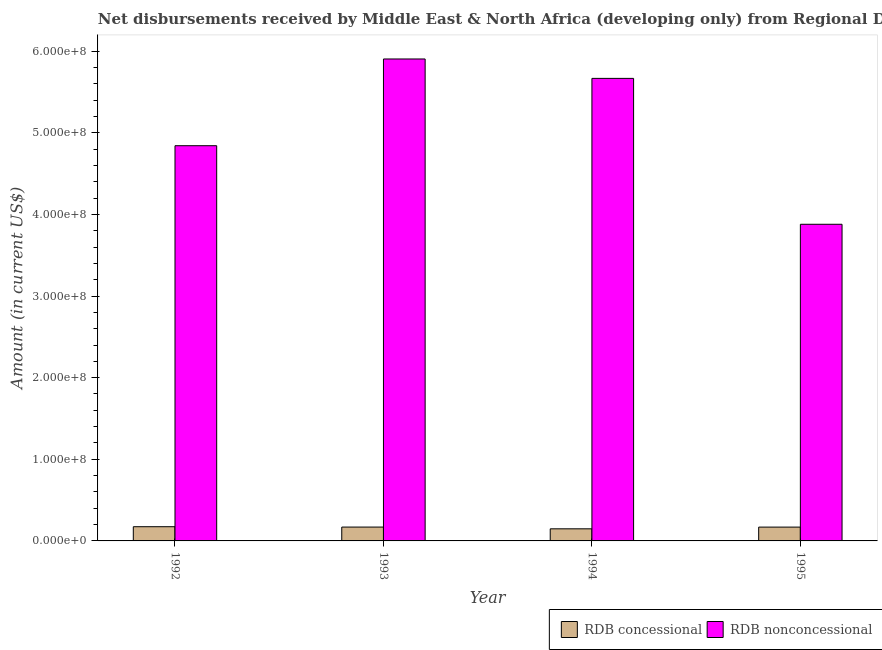How many different coloured bars are there?
Provide a short and direct response. 2. How many groups of bars are there?
Keep it short and to the point. 4. How many bars are there on the 2nd tick from the right?
Offer a very short reply. 2. What is the net concessional disbursements from rdb in 1995?
Provide a short and direct response. 1.69e+07. Across all years, what is the maximum net concessional disbursements from rdb?
Offer a terse response. 1.74e+07. Across all years, what is the minimum net concessional disbursements from rdb?
Give a very brief answer. 1.48e+07. What is the total net non concessional disbursements from rdb in the graph?
Ensure brevity in your answer.  2.03e+09. What is the difference between the net concessional disbursements from rdb in 1992 and that in 1995?
Offer a terse response. 4.81e+05. What is the difference between the net non concessional disbursements from rdb in 1994 and the net concessional disbursements from rdb in 1995?
Keep it short and to the point. 1.79e+08. What is the average net concessional disbursements from rdb per year?
Offer a very short reply. 1.65e+07. What is the ratio of the net concessional disbursements from rdb in 1992 to that in 1994?
Make the answer very short. 1.17. Is the net concessional disbursements from rdb in 1993 less than that in 1994?
Offer a terse response. No. What is the difference between the highest and the second highest net non concessional disbursements from rdb?
Give a very brief answer. 2.38e+07. What is the difference between the highest and the lowest net concessional disbursements from rdb?
Give a very brief answer. 2.59e+06. What does the 1st bar from the left in 1994 represents?
Your answer should be compact. RDB concessional. What does the 1st bar from the right in 1992 represents?
Make the answer very short. RDB nonconcessional. Are all the bars in the graph horizontal?
Keep it short and to the point. No. Are the values on the major ticks of Y-axis written in scientific E-notation?
Provide a succinct answer. Yes. Does the graph contain any zero values?
Keep it short and to the point. No. Does the graph contain grids?
Ensure brevity in your answer.  No. Where does the legend appear in the graph?
Give a very brief answer. Bottom right. How many legend labels are there?
Offer a very short reply. 2. What is the title of the graph?
Keep it short and to the point. Net disbursements received by Middle East & North Africa (developing only) from Regional Development Bank. What is the Amount (in current US$) of RDB concessional in 1992?
Offer a very short reply. 1.74e+07. What is the Amount (in current US$) of RDB nonconcessional in 1992?
Make the answer very short. 4.84e+08. What is the Amount (in current US$) of RDB concessional in 1993?
Your response must be concise. 1.70e+07. What is the Amount (in current US$) in RDB nonconcessional in 1993?
Keep it short and to the point. 5.90e+08. What is the Amount (in current US$) in RDB concessional in 1994?
Your answer should be compact. 1.48e+07. What is the Amount (in current US$) of RDB nonconcessional in 1994?
Your answer should be compact. 5.67e+08. What is the Amount (in current US$) in RDB concessional in 1995?
Keep it short and to the point. 1.69e+07. What is the Amount (in current US$) of RDB nonconcessional in 1995?
Offer a very short reply. 3.88e+08. Across all years, what is the maximum Amount (in current US$) in RDB concessional?
Provide a short and direct response. 1.74e+07. Across all years, what is the maximum Amount (in current US$) of RDB nonconcessional?
Your answer should be compact. 5.90e+08. Across all years, what is the minimum Amount (in current US$) in RDB concessional?
Your answer should be very brief. 1.48e+07. Across all years, what is the minimum Amount (in current US$) of RDB nonconcessional?
Provide a succinct answer. 3.88e+08. What is the total Amount (in current US$) of RDB concessional in the graph?
Your response must be concise. 6.61e+07. What is the total Amount (in current US$) in RDB nonconcessional in the graph?
Give a very brief answer. 2.03e+09. What is the difference between the Amount (in current US$) of RDB concessional in 1992 and that in 1993?
Offer a very short reply. 4.39e+05. What is the difference between the Amount (in current US$) of RDB nonconcessional in 1992 and that in 1993?
Provide a short and direct response. -1.06e+08. What is the difference between the Amount (in current US$) of RDB concessional in 1992 and that in 1994?
Your answer should be compact. 2.59e+06. What is the difference between the Amount (in current US$) of RDB nonconcessional in 1992 and that in 1994?
Give a very brief answer. -8.25e+07. What is the difference between the Amount (in current US$) in RDB concessional in 1992 and that in 1995?
Your answer should be compact. 4.81e+05. What is the difference between the Amount (in current US$) in RDB nonconcessional in 1992 and that in 1995?
Provide a short and direct response. 9.62e+07. What is the difference between the Amount (in current US$) in RDB concessional in 1993 and that in 1994?
Your answer should be very brief. 2.15e+06. What is the difference between the Amount (in current US$) of RDB nonconcessional in 1993 and that in 1994?
Offer a terse response. 2.38e+07. What is the difference between the Amount (in current US$) in RDB concessional in 1993 and that in 1995?
Make the answer very short. 4.20e+04. What is the difference between the Amount (in current US$) in RDB nonconcessional in 1993 and that in 1995?
Offer a very short reply. 2.02e+08. What is the difference between the Amount (in current US$) in RDB concessional in 1994 and that in 1995?
Provide a succinct answer. -2.11e+06. What is the difference between the Amount (in current US$) in RDB nonconcessional in 1994 and that in 1995?
Give a very brief answer. 1.79e+08. What is the difference between the Amount (in current US$) in RDB concessional in 1992 and the Amount (in current US$) in RDB nonconcessional in 1993?
Your answer should be compact. -5.73e+08. What is the difference between the Amount (in current US$) in RDB concessional in 1992 and the Amount (in current US$) in RDB nonconcessional in 1994?
Keep it short and to the point. -5.49e+08. What is the difference between the Amount (in current US$) of RDB concessional in 1992 and the Amount (in current US$) of RDB nonconcessional in 1995?
Make the answer very short. -3.70e+08. What is the difference between the Amount (in current US$) in RDB concessional in 1993 and the Amount (in current US$) in RDB nonconcessional in 1994?
Give a very brief answer. -5.50e+08. What is the difference between the Amount (in current US$) in RDB concessional in 1993 and the Amount (in current US$) in RDB nonconcessional in 1995?
Keep it short and to the point. -3.71e+08. What is the difference between the Amount (in current US$) in RDB concessional in 1994 and the Amount (in current US$) in RDB nonconcessional in 1995?
Offer a terse response. -3.73e+08. What is the average Amount (in current US$) in RDB concessional per year?
Offer a very short reply. 1.65e+07. What is the average Amount (in current US$) of RDB nonconcessional per year?
Your answer should be compact. 5.07e+08. In the year 1992, what is the difference between the Amount (in current US$) in RDB concessional and Amount (in current US$) in RDB nonconcessional?
Offer a very short reply. -4.67e+08. In the year 1993, what is the difference between the Amount (in current US$) of RDB concessional and Amount (in current US$) of RDB nonconcessional?
Give a very brief answer. -5.73e+08. In the year 1994, what is the difference between the Amount (in current US$) of RDB concessional and Amount (in current US$) of RDB nonconcessional?
Keep it short and to the point. -5.52e+08. In the year 1995, what is the difference between the Amount (in current US$) in RDB concessional and Amount (in current US$) in RDB nonconcessional?
Provide a succinct answer. -3.71e+08. What is the ratio of the Amount (in current US$) of RDB concessional in 1992 to that in 1993?
Your response must be concise. 1.03. What is the ratio of the Amount (in current US$) of RDB nonconcessional in 1992 to that in 1993?
Your answer should be compact. 0.82. What is the ratio of the Amount (in current US$) of RDB concessional in 1992 to that in 1994?
Make the answer very short. 1.17. What is the ratio of the Amount (in current US$) in RDB nonconcessional in 1992 to that in 1994?
Provide a succinct answer. 0.85. What is the ratio of the Amount (in current US$) of RDB concessional in 1992 to that in 1995?
Provide a succinct answer. 1.03. What is the ratio of the Amount (in current US$) in RDB nonconcessional in 1992 to that in 1995?
Provide a succinct answer. 1.25. What is the ratio of the Amount (in current US$) of RDB concessional in 1993 to that in 1994?
Provide a short and direct response. 1.15. What is the ratio of the Amount (in current US$) in RDB nonconcessional in 1993 to that in 1994?
Provide a short and direct response. 1.04. What is the ratio of the Amount (in current US$) of RDB concessional in 1993 to that in 1995?
Your answer should be very brief. 1. What is the ratio of the Amount (in current US$) in RDB nonconcessional in 1993 to that in 1995?
Provide a succinct answer. 1.52. What is the ratio of the Amount (in current US$) of RDB concessional in 1994 to that in 1995?
Make the answer very short. 0.88. What is the ratio of the Amount (in current US$) in RDB nonconcessional in 1994 to that in 1995?
Your answer should be compact. 1.46. What is the difference between the highest and the second highest Amount (in current US$) in RDB concessional?
Your answer should be very brief. 4.39e+05. What is the difference between the highest and the second highest Amount (in current US$) of RDB nonconcessional?
Provide a succinct answer. 2.38e+07. What is the difference between the highest and the lowest Amount (in current US$) in RDB concessional?
Keep it short and to the point. 2.59e+06. What is the difference between the highest and the lowest Amount (in current US$) of RDB nonconcessional?
Make the answer very short. 2.02e+08. 